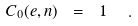Convert formula to latex. <formula><loc_0><loc_0><loc_500><loc_500>C _ { 0 } ( e , n ) \ = \ 1 \ \ .</formula> 